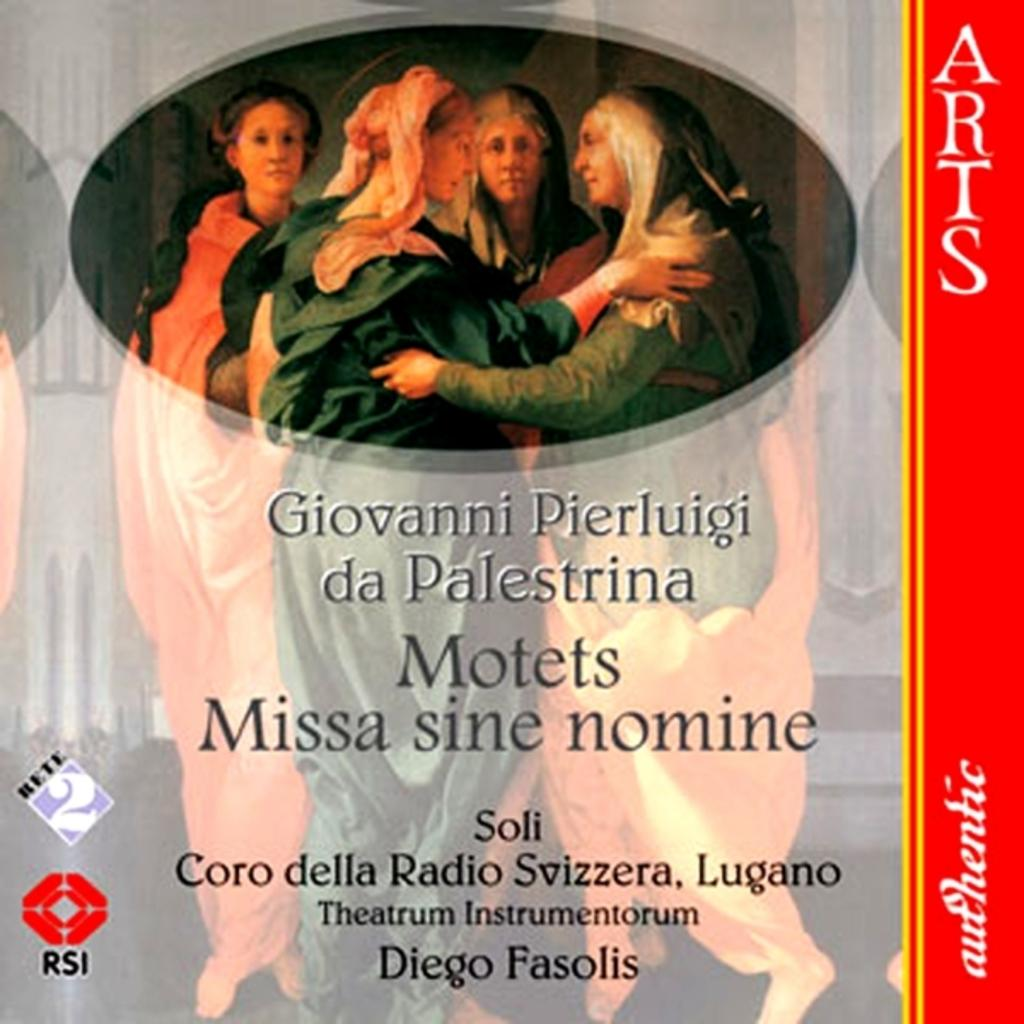Provide a one-sentence caption for the provided image. Missa sine nomine literally means "Mass without a name.". 